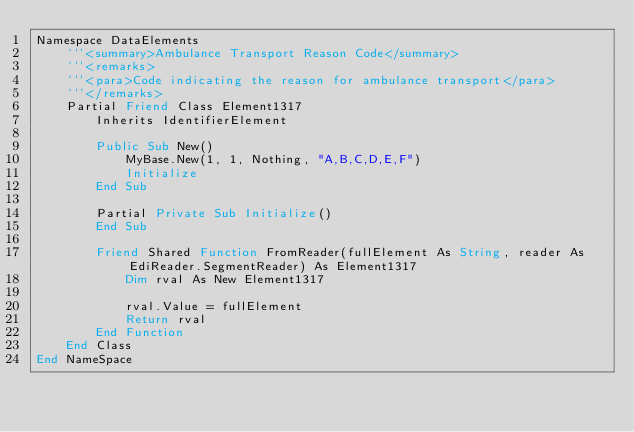<code> <loc_0><loc_0><loc_500><loc_500><_VisualBasic_>Namespace DataElements
    '''<summary>Ambulance Transport Reason Code</summary>
    '''<remarks>
    '''<para>Code indicating the reason for ambulance transport</para>
    '''</remarks>
    Partial Friend Class Element1317
        Inherits IdentifierElement

        Public Sub New()
            MyBase.New(1, 1, Nothing, "A,B,C,D,E,F")
            Initialize
        End Sub

        Partial Private Sub Initialize()
        End Sub

        Friend Shared Function FromReader(fullElement As String, reader As EdiReader.SegmentReader) As Element1317
            Dim rval As New Element1317

            rval.Value = fullElement
            Return rval
        End Function
    End Class
End NameSpace</code> 